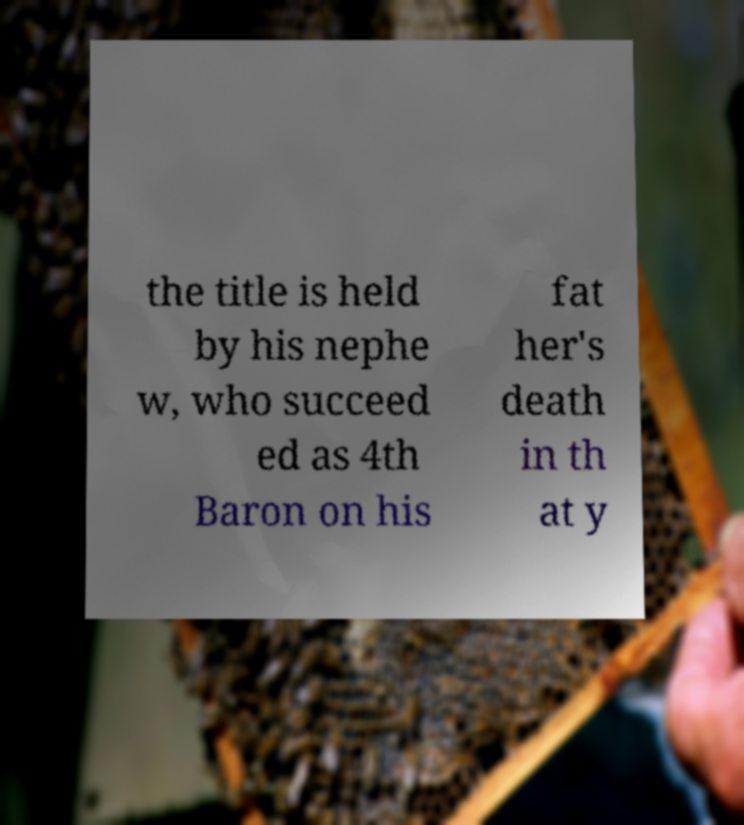Please identify and transcribe the text found in this image. the title is held by his nephe w, who succeed ed as 4th Baron on his fat her's death in th at y 